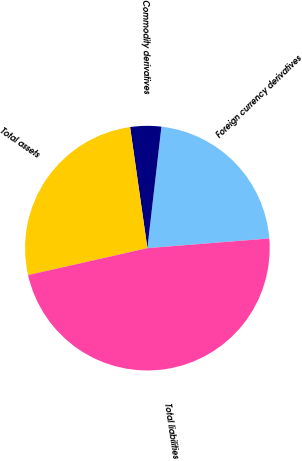Convert chart to OTSL. <chart><loc_0><loc_0><loc_500><loc_500><pie_chart><fcel>Foreign currency derivatives<fcel>Commodity derivatives<fcel>Total assets<fcel>Total liabilities<nl><fcel>21.91%<fcel>4.09%<fcel>26.28%<fcel>47.73%<nl></chart> 